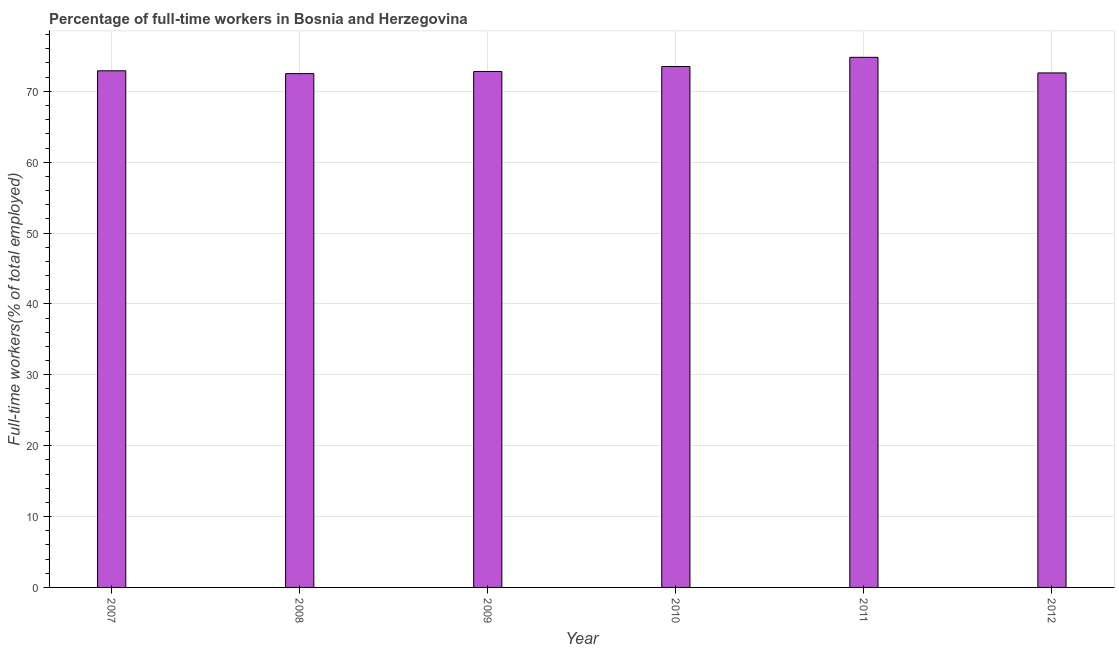Does the graph contain any zero values?
Offer a very short reply. No. Does the graph contain grids?
Provide a short and direct response. Yes. What is the title of the graph?
Keep it short and to the point. Percentage of full-time workers in Bosnia and Herzegovina. What is the label or title of the X-axis?
Offer a terse response. Year. What is the label or title of the Y-axis?
Give a very brief answer. Full-time workers(% of total employed). What is the percentage of full-time workers in 2011?
Give a very brief answer. 74.8. Across all years, what is the maximum percentage of full-time workers?
Offer a terse response. 74.8. Across all years, what is the minimum percentage of full-time workers?
Ensure brevity in your answer.  72.5. In which year was the percentage of full-time workers minimum?
Your answer should be compact. 2008. What is the sum of the percentage of full-time workers?
Make the answer very short. 439.1. What is the average percentage of full-time workers per year?
Your answer should be compact. 73.18. What is the median percentage of full-time workers?
Provide a succinct answer. 72.85. In how many years, is the percentage of full-time workers greater than 74 %?
Offer a very short reply. 1. Do a majority of the years between 2011 and 2010 (inclusive) have percentage of full-time workers greater than 60 %?
Provide a succinct answer. No. In how many years, is the percentage of full-time workers greater than the average percentage of full-time workers taken over all years?
Your answer should be compact. 2. How many bars are there?
Your response must be concise. 6. How many years are there in the graph?
Your answer should be compact. 6. What is the difference between two consecutive major ticks on the Y-axis?
Ensure brevity in your answer.  10. What is the Full-time workers(% of total employed) in 2007?
Offer a terse response. 72.9. What is the Full-time workers(% of total employed) in 2008?
Keep it short and to the point. 72.5. What is the Full-time workers(% of total employed) of 2009?
Provide a succinct answer. 72.8. What is the Full-time workers(% of total employed) in 2010?
Your answer should be compact. 73.5. What is the Full-time workers(% of total employed) of 2011?
Offer a very short reply. 74.8. What is the Full-time workers(% of total employed) of 2012?
Provide a succinct answer. 72.6. What is the difference between the Full-time workers(% of total employed) in 2007 and 2008?
Offer a very short reply. 0.4. What is the difference between the Full-time workers(% of total employed) in 2007 and 2010?
Give a very brief answer. -0.6. What is the difference between the Full-time workers(% of total employed) in 2007 and 2011?
Ensure brevity in your answer.  -1.9. What is the difference between the Full-time workers(% of total employed) in 2007 and 2012?
Provide a short and direct response. 0.3. What is the difference between the Full-time workers(% of total employed) in 2008 and 2010?
Provide a short and direct response. -1. What is the difference between the Full-time workers(% of total employed) in 2008 and 2011?
Provide a succinct answer. -2.3. What is the difference between the Full-time workers(% of total employed) in 2008 and 2012?
Your response must be concise. -0.1. What is the difference between the Full-time workers(% of total employed) in 2009 and 2010?
Provide a short and direct response. -0.7. What is the difference between the Full-time workers(% of total employed) in 2009 and 2011?
Offer a terse response. -2. What is the difference between the Full-time workers(% of total employed) in 2010 and 2011?
Your answer should be very brief. -1.3. What is the difference between the Full-time workers(% of total employed) in 2010 and 2012?
Your response must be concise. 0.9. What is the difference between the Full-time workers(% of total employed) in 2011 and 2012?
Keep it short and to the point. 2.2. What is the ratio of the Full-time workers(% of total employed) in 2007 to that in 2009?
Offer a terse response. 1. What is the ratio of the Full-time workers(% of total employed) in 2007 to that in 2010?
Your answer should be compact. 0.99. What is the ratio of the Full-time workers(% of total employed) in 2007 to that in 2012?
Your answer should be very brief. 1. What is the ratio of the Full-time workers(% of total employed) in 2008 to that in 2010?
Your answer should be compact. 0.99. What is the ratio of the Full-time workers(% of total employed) in 2009 to that in 2010?
Give a very brief answer. 0.99. What is the ratio of the Full-time workers(% of total employed) in 2009 to that in 2011?
Keep it short and to the point. 0.97. What is the ratio of the Full-time workers(% of total employed) in 2010 to that in 2012?
Offer a terse response. 1.01. 